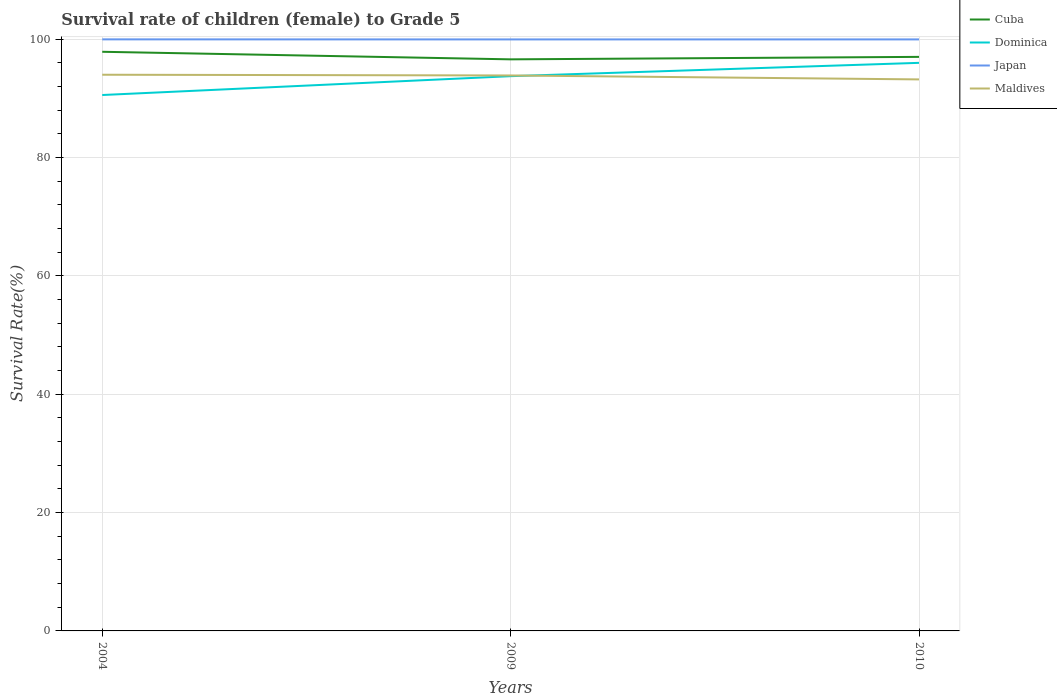Does the line corresponding to Japan intersect with the line corresponding to Maldives?
Ensure brevity in your answer.  No. Is the number of lines equal to the number of legend labels?
Provide a succinct answer. Yes. Across all years, what is the maximum survival rate of female children to grade 5 in Dominica?
Your answer should be compact. 90.54. What is the total survival rate of female children to grade 5 in Dominica in the graph?
Your answer should be compact. -2.25. What is the difference between the highest and the second highest survival rate of female children to grade 5 in Japan?
Make the answer very short. 0.01. How many lines are there?
Provide a short and direct response. 4. What is the difference between two consecutive major ticks on the Y-axis?
Offer a terse response. 20. Are the values on the major ticks of Y-axis written in scientific E-notation?
Make the answer very short. No. Does the graph contain any zero values?
Ensure brevity in your answer.  No. How are the legend labels stacked?
Offer a very short reply. Vertical. What is the title of the graph?
Provide a succinct answer. Survival rate of children (female) to Grade 5. What is the label or title of the Y-axis?
Make the answer very short. Survival Rate(%). What is the Survival Rate(%) in Cuba in 2004?
Give a very brief answer. 97.84. What is the Survival Rate(%) of Dominica in 2004?
Offer a very short reply. 90.54. What is the Survival Rate(%) of Japan in 2004?
Make the answer very short. 99.94. What is the Survival Rate(%) of Maldives in 2004?
Offer a very short reply. 93.96. What is the Survival Rate(%) in Cuba in 2009?
Keep it short and to the point. 96.57. What is the Survival Rate(%) in Dominica in 2009?
Offer a very short reply. 93.72. What is the Survival Rate(%) of Japan in 2009?
Give a very brief answer. 99.93. What is the Survival Rate(%) of Maldives in 2009?
Offer a very short reply. 93.84. What is the Survival Rate(%) in Cuba in 2010?
Your response must be concise. 96.98. What is the Survival Rate(%) in Dominica in 2010?
Provide a short and direct response. 95.98. What is the Survival Rate(%) of Japan in 2010?
Provide a succinct answer. 99.94. What is the Survival Rate(%) in Maldives in 2010?
Offer a terse response. 93.18. Across all years, what is the maximum Survival Rate(%) of Cuba?
Your answer should be very brief. 97.84. Across all years, what is the maximum Survival Rate(%) of Dominica?
Your answer should be very brief. 95.98. Across all years, what is the maximum Survival Rate(%) in Japan?
Provide a succinct answer. 99.94. Across all years, what is the maximum Survival Rate(%) in Maldives?
Offer a very short reply. 93.96. Across all years, what is the minimum Survival Rate(%) of Cuba?
Keep it short and to the point. 96.57. Across all years, what is the minimum Survival Rate(%) in Dominica?
Provide a succinct answer. 90.54. Across all years, what is the minimum Survival Rate(%) of Japan?
Give a very brief answer. 99.93. Across all years, what is the minimum Survival Rate(%) of Maldives?
Offer a very short reply. 93.18. What is the total Survival Rate(%) of Cuba in the graph?
Offer a very short reply. 291.39. What is the total Survival Rate(%) of Dominica in the graph?
Ensure brevity in your answer.  280.24. What is the total Survival Rate(%) of Japan in the graph?
Offer a terse response. 299.81. What is the total Survival Rate(%) of Maldives in the graph?
Your answer should be very brief. 280.99. What is the difference between the Survival Rate(%) in Cuba in 2004 and that in 2009?
Your answer should be compact. 1.28. What is the difference between the Survival Rate(%) of Dominica in 2004 and that in 2009?
Your answer should be compact. -3.18. What is the difference between the Survival Rate(%) of Japan in 2004 and that in 2009?
Give a very brief answer. 0.01. What is the difference between the Survival Rate(%) of Maldives in 2004 and that in 2009?
Your answer should be very brief. 0.12. What is the difference between the Survival Rate(%) of Cuba in 2004 and that in 2010?
Your response must be concise. 0.86. What is the difference between the Survival Rate(%) of Dominica in 2004 and that in 2010?
Your response must be concise. -5.44. What is the difference between the Survival Rate(%) of Japan in 2004 and that in 2010?
Offer a terse response. 0.01. What is the difference between the Survival Rate(%) in Maldives in 2004 and that in 2010?
Ensure brevity in your answer.  0.79. What is the difference between the Survival Rate(%) in Cuba in 2009 and that in 2010?
Keep it short and to the point. -0.42. What is the difference between the Survival Rate(%) in Dominica in 2009 and that in 2010?
Give a very brief answer. -2.25. What is the difference between the Survival Rate(%) in Japan in 2009 and that in 2010?
Provide a short and direct response. -0. What is the difference between the Survival Rate(%) of Maldives in 2009 and that in 2010?
Offer a very short reply. 0.67. What is the difference between the Survival Rate(%) in Cuba in 2004 and the Survival Rate(%) in Dominica in 2009?
Offer a terse response. 4.12. What is the difference between the Survival Rate(%) in Cuba in 2004 and the Survival Rate(%) in Japan in 2009?
Your answer should be very brief. -2.09. What is the difference between the Survival Rate(%) in Cuba in 2004 and the Survival Rate(%) in Maldives in 2009?
Your answer should be compact. 4. What is the difference between the Survival Rate(%) of Dominica in 2004 and the Survival Rate(%) of Japan in 2009?
Provide a short and direct response. -9.39. What is the difference between the Survival Rate(%) of Dominica in 2004 and the Survival Rate(%) of Maldives in 2009?
Your answer should be very brief. -3.31. What is the difference between the Survival Rate(%) in Japan in 2004 and the Survival Rate(%) in Maldives in 2009?
Provide a short and direct response. 6.1. What is the difference between the Survival Rate(%) in Cuba in 2004 and the Survival Rate(%) in Dominica in 2010?
Your response must be concise. 1.87. What is the difference between the Survival Rate(%) in Cuba in 2004 and the Survival Rate(%) in Japan in 2010?
Give a very brief answer. -2.09. What is the difference between the Survival Rate(%) in Cuba in 2004 and the Survival Rate(%) in Maldives in 2010?
Your answer should be compact. 4.67. What is the difference between the Survival Rate(%) of Dominica in 2004 and the Survival Rate(%) of Japan in 2010?
Offer a very short reply. -9.4. What is the difference between the Survival Rate(%) of Dominica in 2004 and the Survival Rate(%) of Maldives in 2010?
Provide a succinct answer. -2.64. What is the difference between the Survival Rate(%) in Japan in 2004 and the Survival Rate(%) in Maldives in 2010?
Provide a short and direct response. 6.77. What is the difference between the Survival Rate(%) in Cuba in 2009 and the Survival Rate(%) in Dominica in 2010?
Provide a short and direct response. 0.59. What is the difference between the Survival Rate(%) of Cuba in 2009 and the Survival Rate(%) of Japan in 2010?
Provide a succinct answer. -3.37. What is the difference between the Survival Rate(%) of Cuba in 2009 and the Survival Rate(%) of Maldives in 2010?
Offer a very short reply. 3.39. What is the difference between the Survival Rate(%) of Dominica in 2009 and the Survival Rate(%) of Japan in 2010?
Your answer should be very brief. -6.21. What is the difference between the Survival Rate(%) in Dominica in 2009 and the Survival Rate(%) in Maldives in 2010?
Your answer should be compact. 0.55. What is the difference between the Survival Rate(%) of Japan in 2009 and the Survival Rate(%) of Maldives in 2010?
Keep it short and to the point. 6.75. What is the average Survival Rate(%) of Cuba per year?
Offer a very short reply. 97.13. What is the average Survival Rate(%) in Dominica per year?
Provide a succinct answer. 93.41. What is the average Survival Rate(%) of Japan per year?
Provide a short and direct response. 99.94. What is the average Survival Rate(%) of Maldives per year?
Offer a terse response. 93.66. In the year 2004, what is the difference between the Survival Rate(%) in Cuba and Survival Rate(%) in Dominica?
Make the answer very short. 7.31. In the year 2004, what is the difference between the Survival Rate(%) in Cuba and Survival Rate(%) in Japan?
Give a very brief answer. -2.1. In the year 2004, what is the difference between the Survival Rate(%) in Cuba and Survival Rate(%) in Maldives?
Provide a short and direct response. 3.88. In the year 2004, what is the difference between the Survival Rate(%) of Dominica and Survival Rate(%) of Japan?
Your answer should be compact. -9.4. In the year 2004, what is the difference between the Survival Rate(%) of Dominica and Survival Rate(%) of Maldives?
Ensure brevity in your answer.  -3.43. In the year 2004, what is the difference between the Survival Rate(%) of Japan and Survival Rate(%) of Maldives?
Offer a very short reply. 5.98. In the year 2009, what is the difference between the Survival Rate(%) in Cuba and Survival Rate(%) in Dominica?
Offer a terse response. 2.84. In the year 2009, what is the difference between the Survival Rate(%) in Cuba and Survival Rate(%) in Japan?
Your response must be concise. -3.37. In the year 2009, what is the difference between the Survival Rate(%) of Cuba and Survival Rate(%) of Maldives?
Give a very brief answer. 2.72. In the year 2009, what is the difference between the Survival Rate(%) in Dominica and Survival Rate(%) in Japan?
Give a very brief answer. -6.21. In the year 2009, what is the difference between the Survival Rate(%) in Dominica and Survival Rate(%) in Maldives?
Keep it short and to the point. -0.12. In the year 2009, what is the difference between the Survival Rate(%) of Japan and Survival Rate(%) of Maldives?
Make the answer very short. 6.09. In the year 2010, what is the difference between the Survival Rate(%) in Cuba and Survival Rate(%) in Dominica?
Keep it short and to the point. 1.01. In the year 2010, what is the difference between the Survival Rate(%) of Cuba and Survival Rate(%) of Japan?
Make the answer very short. -2.95. In the year 2010, what is the difference between the Survival Rate(%) in Cuba and Survival Rate(%) in Maldives?
Your response must be concise. 3.81. In the year 2010, what is the difference between the Survival Rate(%) of Dominica and Survival Rate(%) of Japan?
Provide a short and direct response. -3.96. In the year 2010, what is the difference between the Survival Rate(%) of Dominica and Survival Rate(%) of Maldives?
Keep it short and to the point. 2.8. In the year 2010, what is the difference between the Survival Rate(%) in Japan and Survival Rate(%) in Maldives?
Keep it short and to the point. 6.76. What is the ratio of the Survival Rate(%) in Cuba in 2004 to that in 2009?
Your answer should be compact. 1.01. What is the ratio of the Survival Rate(%) of Japan in 2004 to that in 2009?
Make the answer very short. 1. What is the ratio of the Survival Rate(%) in Maldives in 2004 to that in 2009?
Keep it short and to the point. 1. What is the ratio of the Survival Rate(%) in Cuba in 2004 to that in 2010?
Keep it short and to the point. 1.01. What is the ratio of the Survival Rate(%) of Dominica in 2004 to that in 2010?
Make the answer very short. 0.94. What is the ratio of the Survival Rate(%) in Maldives in 2004 to that in 2010?
Ensure brevity in your answer.  1.01. What is the ratio of the Survival Rate(%) in Cuba in 2009 to that in 2010?
Ensure brevity in your answer.  1. What is the ratio of the Survival Rate(%) in Dominica in 2009 to that in 2010?
Provide a short and direct response. 0.98. What is the ratio of the Survival Rate(%) of Japan in 2009 to that in 2010?
Offer a terse response. 1. What is the difference between the highest and the second highest Survival Rate(%) in Cuba?
Your answer should be compact. 0.86. What is the difference between the highest and the second highest Survival Rate(%) in Dominica?
Your answer should be compact. 2.25. What is the difference between the highest and the second highest Survival Rate(%) of Japan?
Offer a terse response. 0.01. What is the difference between the highest and the second highest Survival Rate(%) in Maldives?
Your answer should be compact. 0.12. What is the difference between the highest and the lowest Survival Rate(%) of Cuba?
Give a very brief answer. 1.28. What is the difference between the highest and the lowest Survival Rate(%) of Dominica?
Offer a terse response. 5.44. What is the difference between the highest and the lowest Survival Rate(%) in Japan?
Make the answer very short. 0.01. What is the difference between the highest and the lowest Survival Rate(%) in Maldives?
Keep it short and to the point. 0.79. 